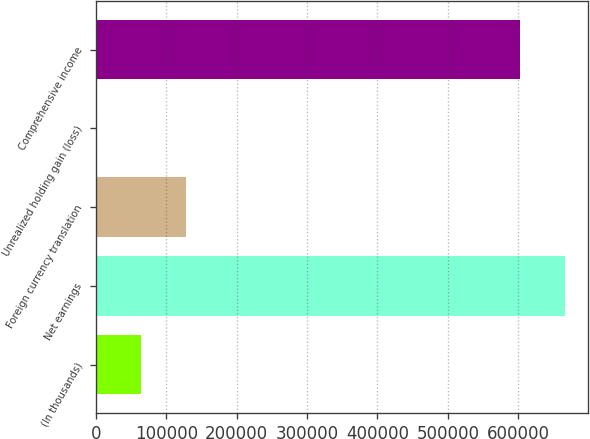<chart> <loc_0><loc_0><loc_500><loc_500><bar_chart><fcel>(In thousands)<fcel>Net earnings<fcel>Foreign currency translation<fcel>Unrealized holding gain (loss)<fcel>Comprehensive income<nl><fcel>63702.4<fcel>666315<fcel>127345<fcel>60<fcel>602673<nl></chart> 